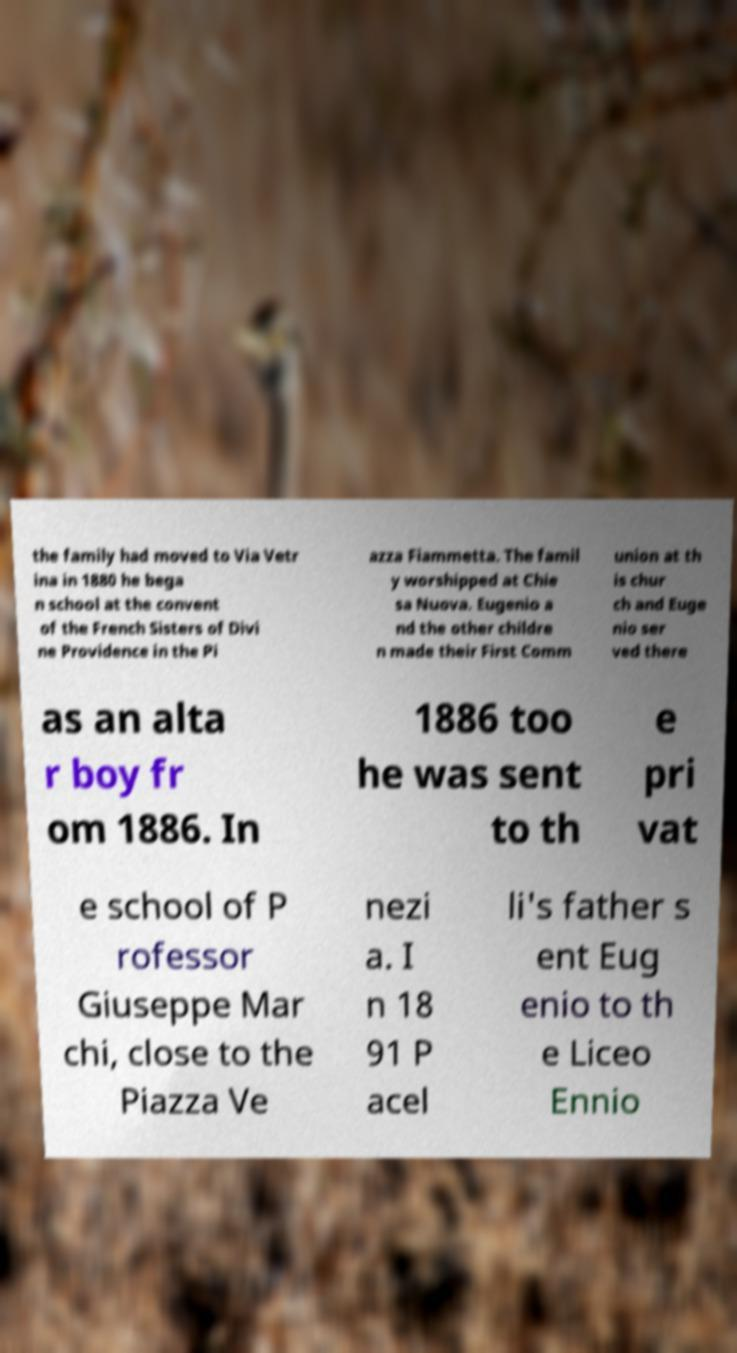Can you read and provide the text displayed in the image?This photo seems to have some interesting text. Can you extract and type it out for me? the family had moved to Via Vetr ina in 1880 he bega n school at the convent of the French Sisters of Divi ne Providence in the Pi azza Fiammetta. The famil y worshipped at Chie sa Nuova. Eugenio a nd the other childre n made their First Comm union at th is chur ch and Euge nio ser ved there as an alta r boy fr om 1886. In 1886 too he was sent to th e pri vat e school of P rofessor Giuseppe Mar chi, close to the Piazza Ve nezi a. I n 18 91 P acel li's father s ent Eug enio to th e Liceo Ennio 